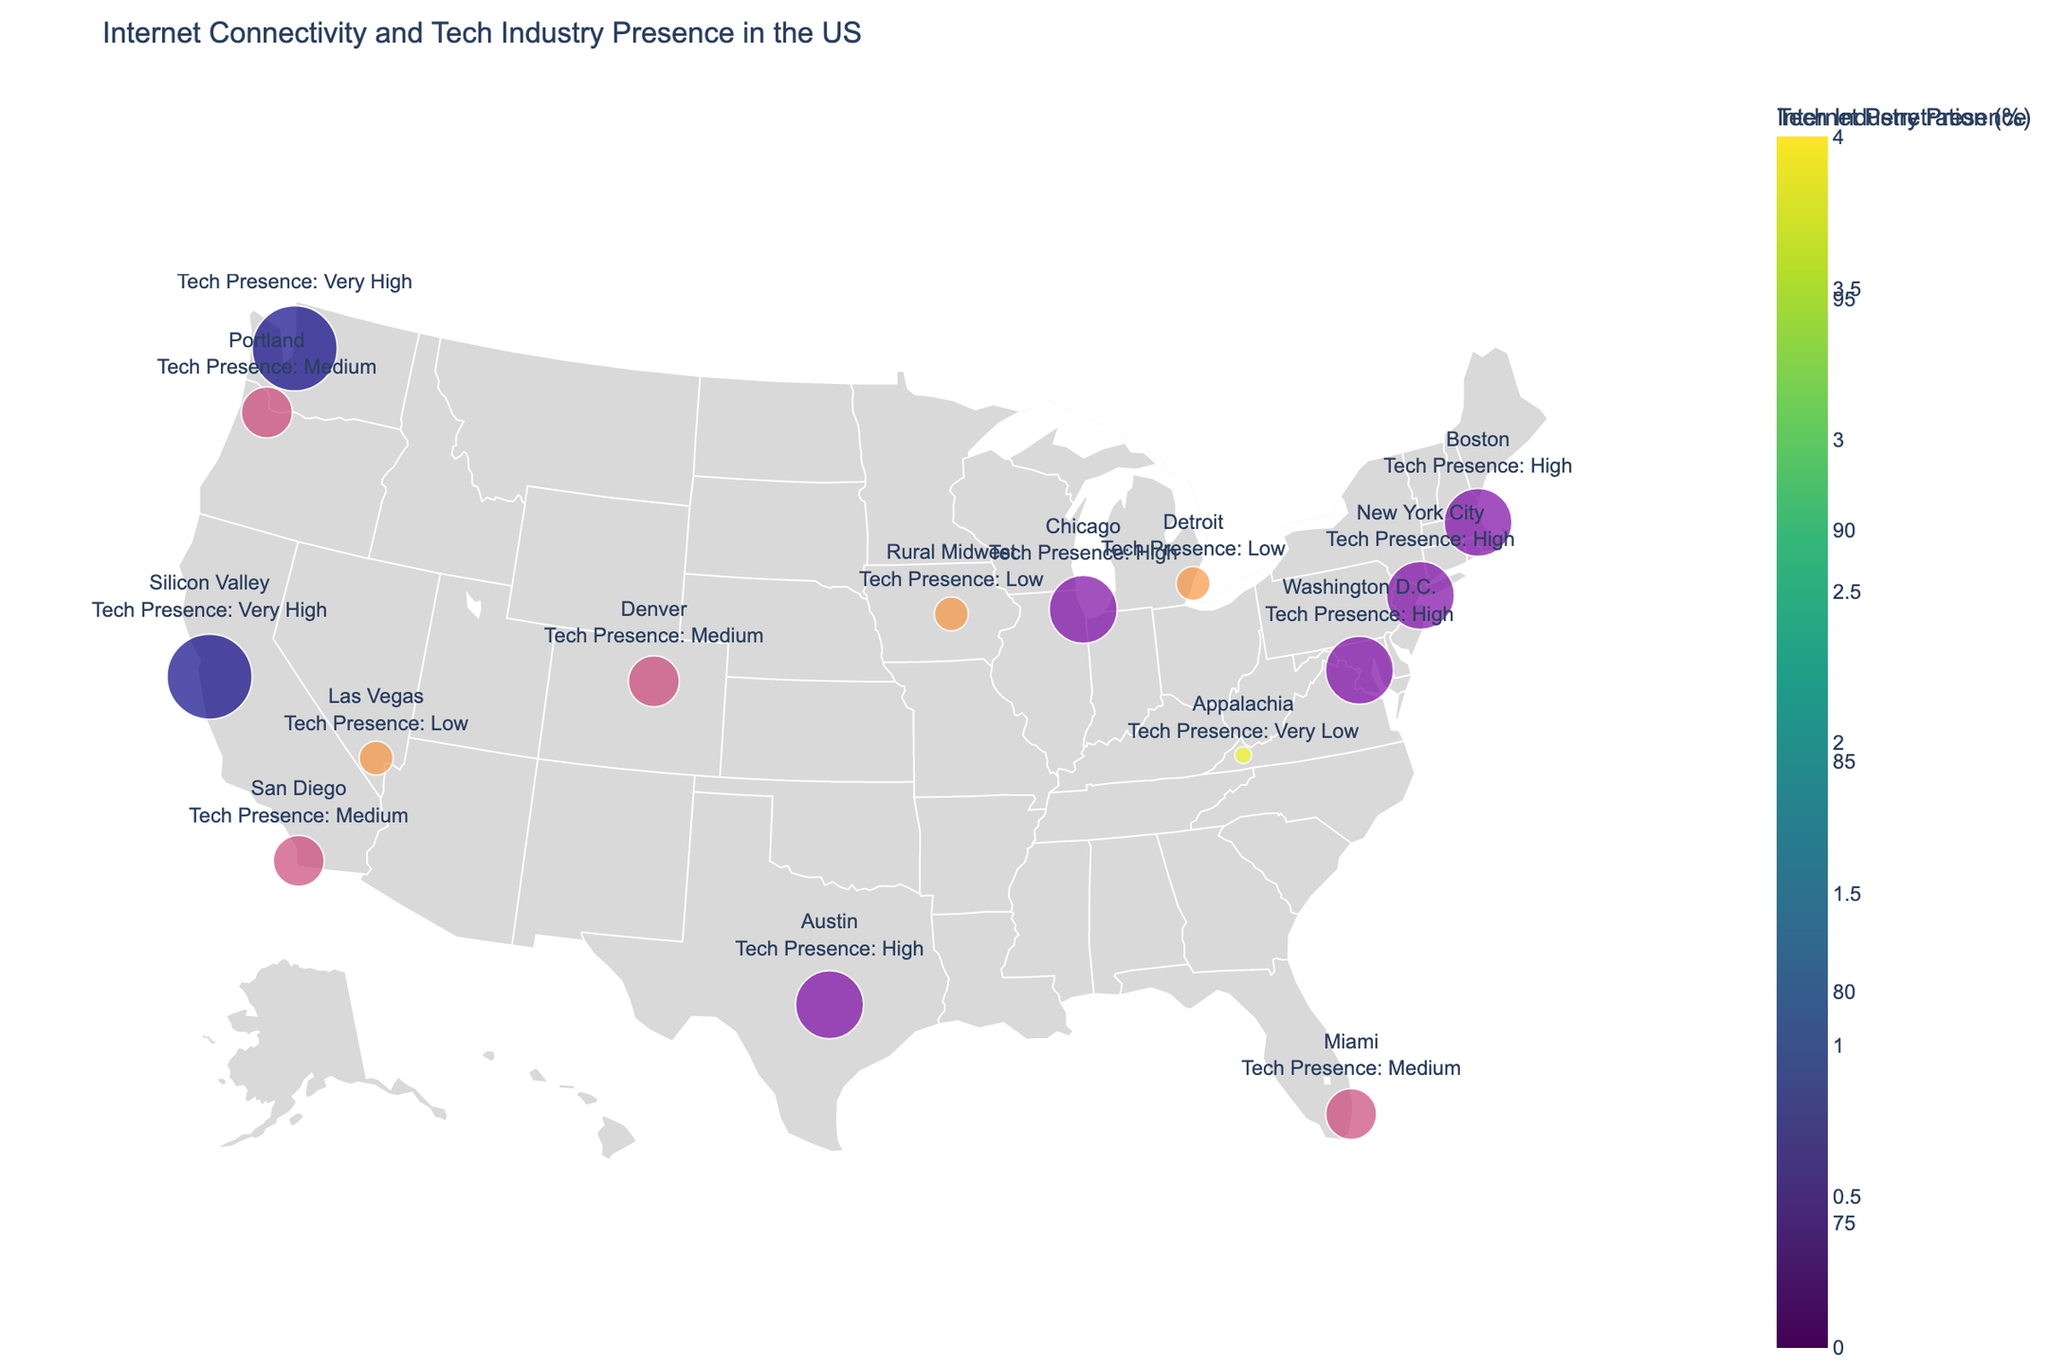What is the title of the figure? The title of the figure is usually found at the top center of the plot. From the provided figure details, the title is "Internet Connectivity and Tech Industry Presence in the US."
Answer: Internet Connectivity and Tech Industry Presence in the US Which region has the highest internet penetration rate and what is that rate? To find this, look at the colorbar and the internet penetration percentage on the map. Based on the provided data, Silicon Valley has the highest internet penetration rate which is 98.5%.
Answer: Silicon Valley, 98.5% Which region has the lowest average broadband speed? Identify the region with the lowest value in the "Average Broadband Speed (Mbps)" column on the map. Appalachia has the lowest average broadband speed of 35 Mbps.
Answer: Appalachia, 35 Mbps Compare the tech industry presence of Silicon Valley and Appalachia. The figure uses markers of different sizes and colors to represent tech industry presence. Silicon Valley is marked as "Very High," while Appalachia is marked as "Very Low."
Answer: Silicon Valley has a Very High tech industry presence, while Appalachia has a Very Low tech industry presence What is the internet penetration rate for New York City compared to Seattle? Look at the internet penetration percentages for New York City and Seattle from the map. New York City has 95.2%, and Seattle has 97.1%.
Answer: New York City's internet penetration rate is 95.2%, while Seattle's is 97.1% Which region shows a tech industry presence marked as "Medium" and also has the highest internet penetration rate within this category? From the map, identify all regions marked as "Medium" in tech industry presence and compare their internet penetration rates. San Diego (95.5%) falls under the "Medium" category and has the highest internet penetration rate within this category.
Answer: San Diego What is the range of average broadband speeds in regions with a "High" tech industry presence? Identify all regions with a "High" tech industry presence and note their broadband speeds. The regions with "High" tech industry presence and their speeds are New York City (180 Mbps), Boston (175 Mbps), and Chicago (150 Mbps). The range is calculated as 180 - 150.
Answer: 150 - 180 Mbps How many regions have an internet penetration rate below 90%? Identify the regions with internet penetration rates below 90% from the map. Detroit, Rural Midwest, and Appalachia are the regions that fall into this category.
Answer: 3 regions 